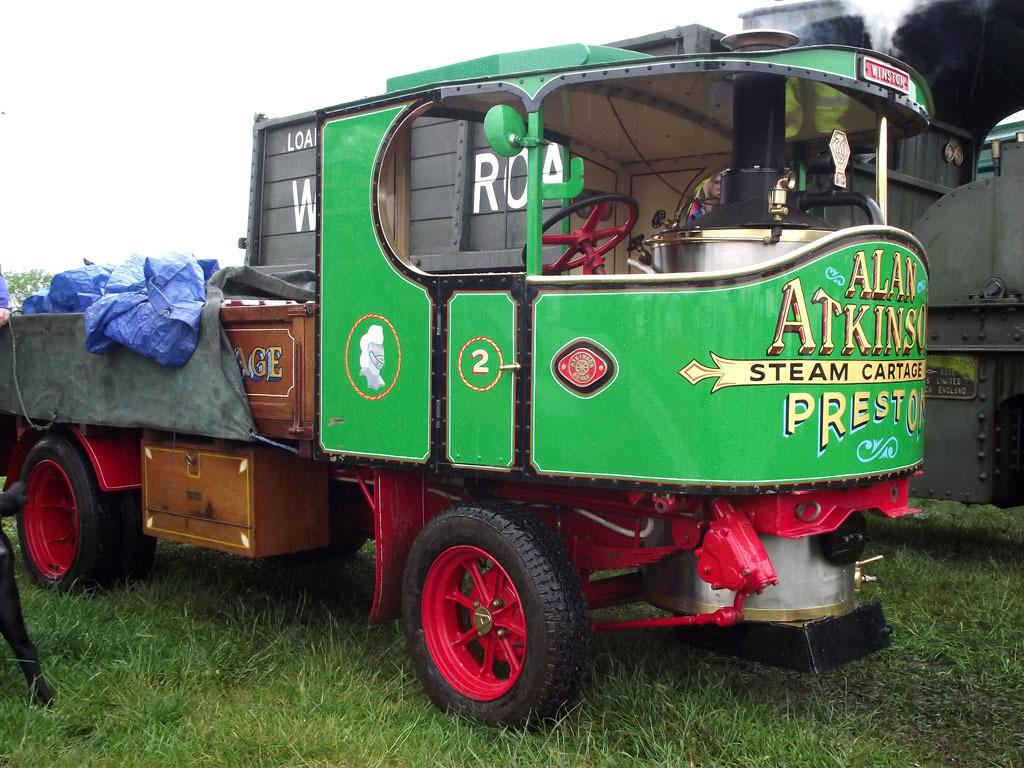What is the main subject in the center of the image? There is a vehicle in the center of the image. What colors can be seen on the vehicle? The vehicle is green and brown in color. Is there any text visible on the vehicle? Yes, there is text written on the vehicle. What type of terrain is visible in the image? There is grass on the ground in the image. How would you describe the sky in the image? The sky is cloudy in the image. How many feet are visible on the vehicle in the image? There are no feet visible on the vehicle in the image, as it is a vehicle and not a living being. 